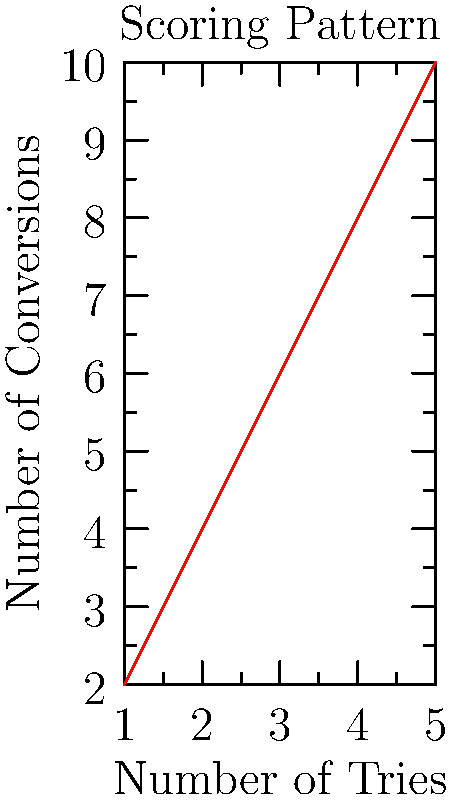In a Rugby League match analysis, the Gold Coast Titans' scoring pattern is represented by the permutation group $G = \langle (1,2,3,4,5) \rangle$. If the graph shows the relationship between tries and conversions, what is the order of the group $G$, and how many unique scoring combinations are possible? To solve this problem, we need to follow these steps:

1. Understand the permutation group:
   $G = \langle (1,2,3,4,5) \rangle$ means the group is generated by the cycle (1,2,3,4,5).

2. Calculate the order of the group:
   The order of a cyclic permutation is equal to its length.
   In this case, the length of the cycle is 5.
   Therefore, the order of the group $G$ is 5.

3. Interpret the graph:
   The graph shows a linear relationship between tries and conversions.
   Each point on the graph represents a unique scoring combination.

4. Count the unique scoring combinations:
   Since there are 5 points on the graph, there are 5 unique scoring combinations.

5. Verify the result:
   The number of unique scoring combinations matches the order of the group $G$.
   This is because each element in the permutation group corresponds to a unique scoring combination.

Therefore, the order of the group $G$ is 5, and there are 5 unique scoring combinations possible.
Answer: Order of $G$: 5; Unique combinations: 5 